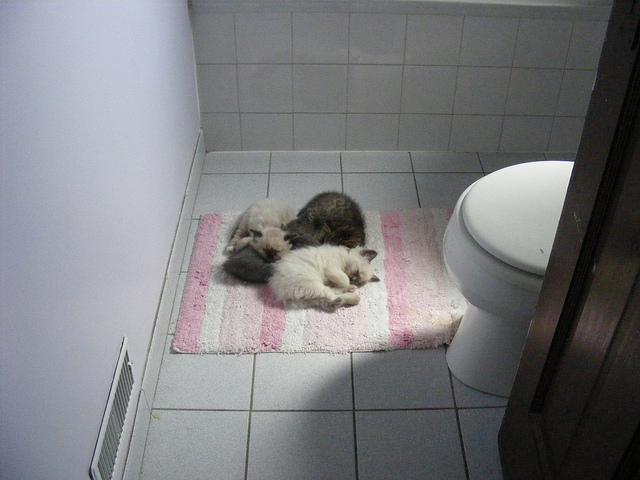Where is this?
Short answer required. Bathroom. How many kittens are there?
Be succinct. 3. What color is the rug?
Concise answer only. Pink and white. What are the kittens doing?
Answer briefly. Sleeping. 